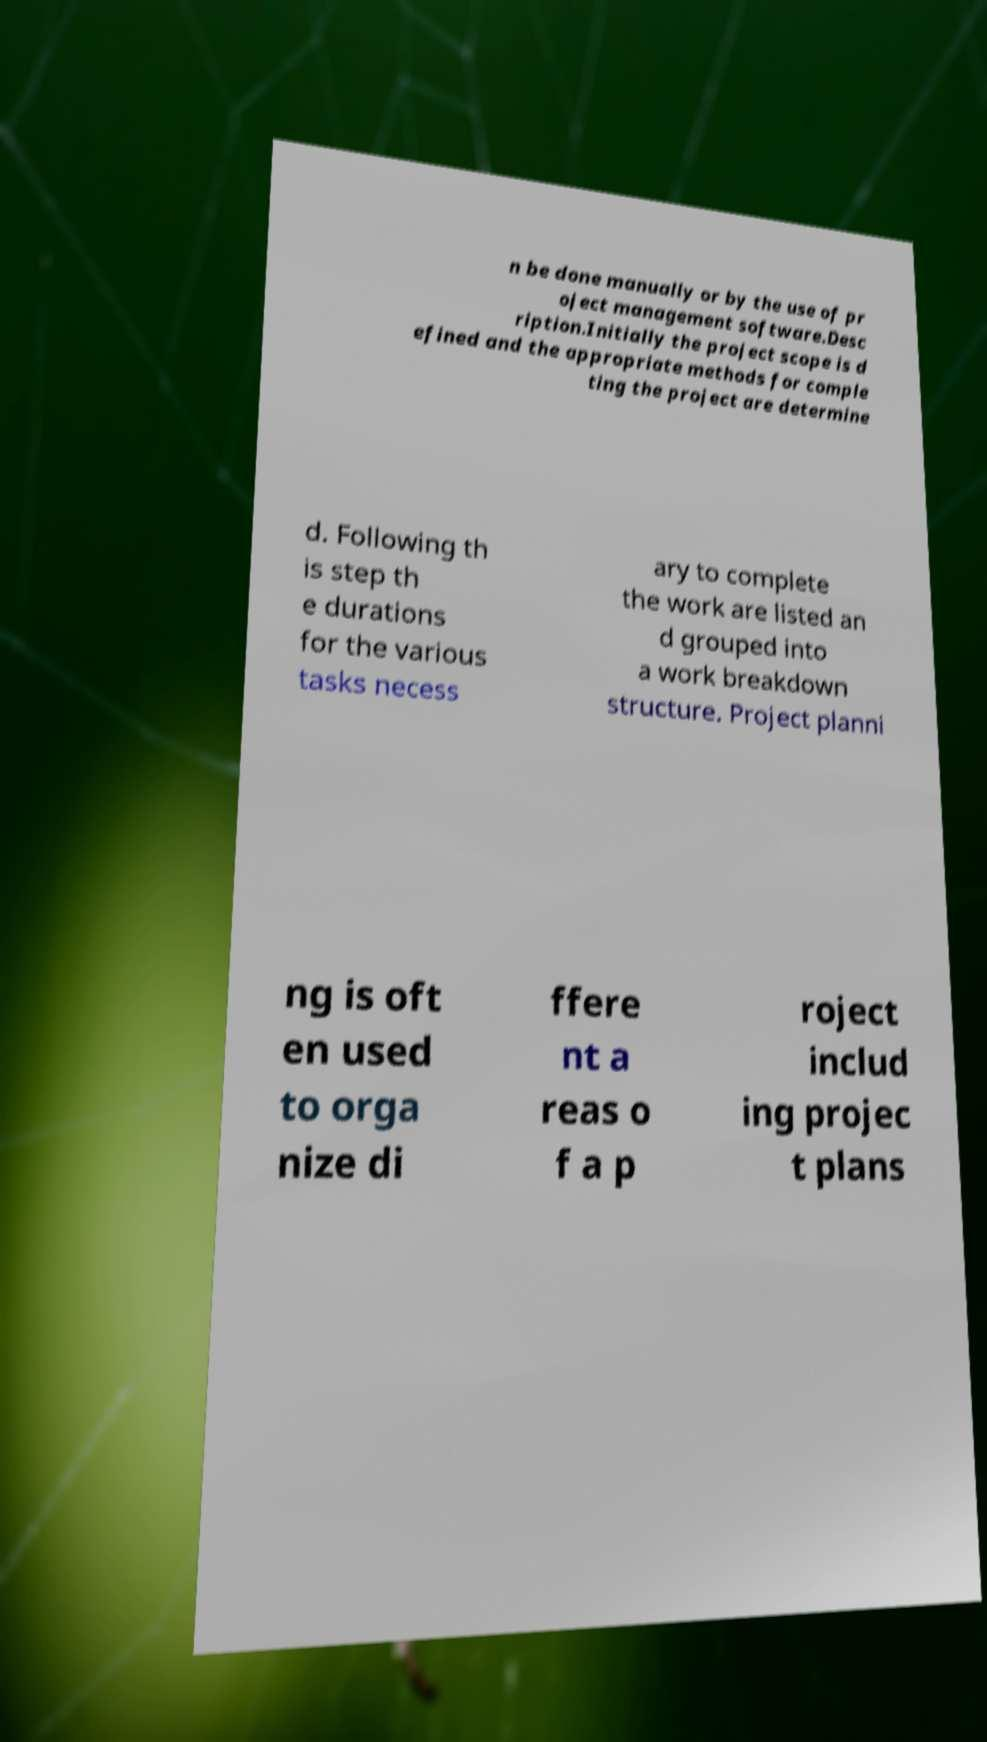Please read and relay the text visible in this image. What does it say? n be done manually or by the use of pr oject management software.Desc ription.Initially the project scope is d efined and the appropriate methods for comple ting the project are determine d. Following th is step th e durations for the various tasks necess ary to complete the work are listed an d grouped into a work breakdown structure. Project planni ng is oft en used to orga nize di ffere nt a reas o f a p roject includ ing projec t plans 